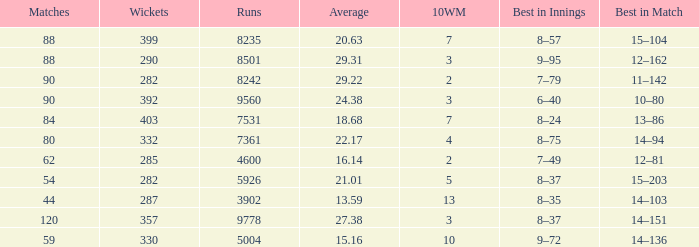What is the sum of runs that are associated with 10WM values over 13? None. 